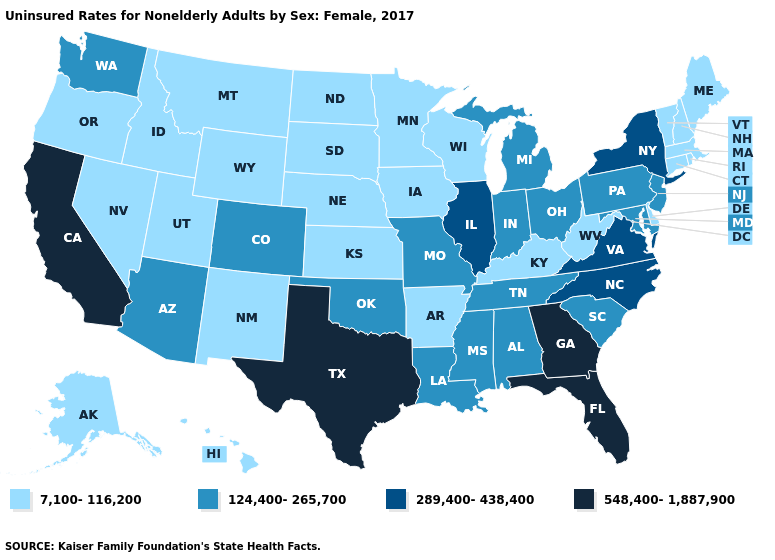What is the value of Iowa?
Answer briefly. 7,100-116,200. What is the value of Wisconsin?
Short answer required. 7,100-116,200. What is the value of Arizona?
Give a very brief answer. 124,400-265,700. What is the value of Ohio?
Answer briefly. 124,400-265,700. What is the value of Mississippi?
Give a very brief answer. 124,400-265,700. Which states have the lowest value in the USA?
Concise answer only. Alaska, Arkansas, Connecticut, Delaware, Hawaii, Idaho, Iowa, Kansas, Kentucky, Maine, Massachusetts, Minnesota, Montana, Nebraska, Nevada, New Hampshire, New Mexico, North Dakota, Oregon, Rhode Island, South Dakota, Utah, Vermont, West Virginia, Wisconsin, Wyoming. Does Colorado have a higher value than Arizona?
Be succinct. No. What is the value of Vermont?
Concise answer only. 7,100-116,200. Which states have the lowest value in the South?
Keep it brief. Arkansas, Delaware, Kentucky, West Virginia. Among the states that border Maine , which have the lowest value?
Quick response, please. New Hampshire. What is the lowest value in the USA?
Answer briefly. 7,100-116,200. What is the highest value in the MidWest ?
Concise answer only. 289,400-438,400. Which states have the highest value in the USA?
Short answer required. California, Florida, Georgia, Texas. What is the value of South Dakota?
Answer briefly. 7,100-116,200. 